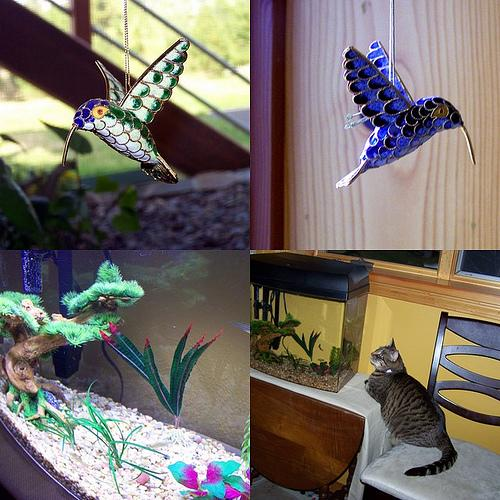What type of birds are in the top images? stained glass 